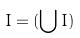Convert formula to latex. <formula><loc_0><loc_0><loc_500><loc_500>I = ( \bigcup I )</formula> 